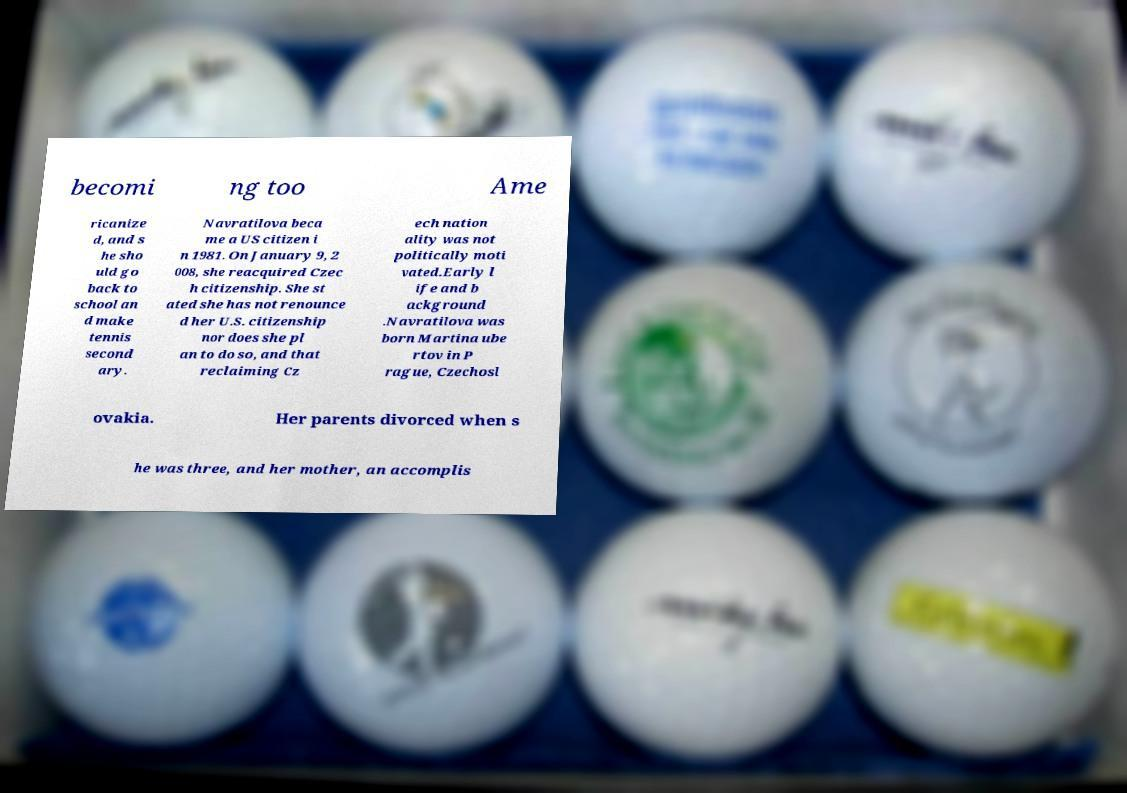For documentation purposes, I need the text within this image transcribed. Could you provide that? becomi ng too Ame ricanize d, and s he sho uld go back to school an d make tennis second ary. Navratilova beca me a US citizen i n 1981. On January 9, 2 008, she reacquired Czec h citizenship. She st ated she has not renounce d her U.S. citizenship nor does she pl an to do so, and that reclaiming Cz ech nation ality was not politically moti vated.Early l ife and b ackground .Navratilova was born Martina ube rtov in P rague, Czechosl ovakia. Her parents divorced when s he was three, and her mother, an accomplis 